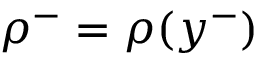Convert formula to latex. <formula><loc_0><loc_0><loc_500><loc_500>\rho ^ { - } = \rho ( y ^ { - } )</formula> 